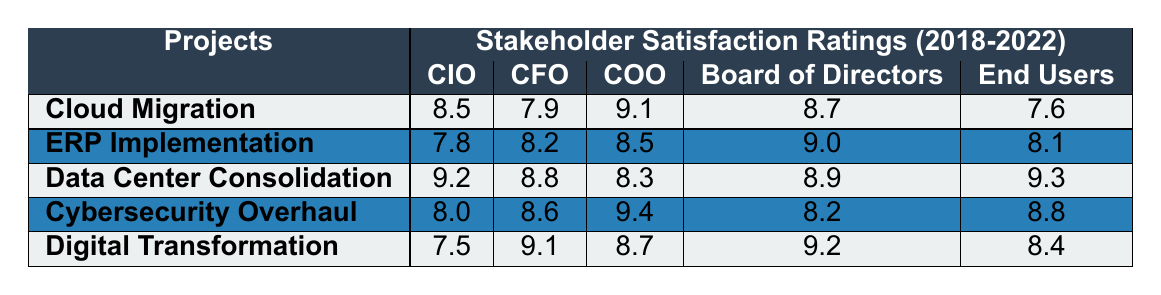What was the highest satisfaction rating for the CIO among all projects? The highest satisfaction rating for the CIO is 9.3, which corresponds to the "Data Center Consolidation" project in 2018.
Answer: 9.3 What is the average satisfaction rating for the CFO across all projects? To calculate the average for the CFO, we sum the ratings: (7.9 + 8.2 + 8.8 + 8.6 + 9.1) = 42.6. Dividing by 5 (the number of projects), we get 42.6/5 = 8.52.
Answer: 8.52 Which project received the lowest satisfaction rating from the Board of Directors? The project with the lowest rating from the Board of Directors is "Cybersecurity Overhaul," with a rating of 8.2 in 2021.
Answer: Cybersecurity Overhaul Did the satisfaction rating for End Users improve in the "Digital Transformation Initiative" project from 2018 to 2022? The End User rating for "Digital Transformation Initiative" initially was 7.5 in 2018 and rose to 8.4 in 2022. Therefore, the rating improved.
Answer: Yes Which project's ratings show the most significant decrease for the COO over the years? Examining COO ratings reveals "Cloud Migration" with ratings of 9.1 in 2018 and 8.3 in 2022 shows a decrease of 0.8, which is the highest decrease.
Answer: Cloud Migration What was the satisfaction rating for the cybersecurity overhaul from the CIO in 2019? The rating for the CIO regarding the Cybersecurity Overhaul project in 2019 is 8.6.
Answer: 8.6 What is the difference in satisfaction ratings between End Users and COO for the "Data Center Consolidation" project? For "Data Center Consolidation," the End Users rated it 9.3, and the COO rated it 8.3. The difference is 9.3 - 8.3 = 1.0.
Answer: 1.0 What percentage of the ratings for the CIO in all projects are above 8.0? The ratings for the CIO are 8.5, 7.8, 9.2, 8.0, and 7.5. Three ratings (8.5, 9.2, 8.0) are above 8.0. This is 3 out of 5, which is 60%.
Answer: 60% In which year did the "ERP Implementation" project receive its highest overall rating? The "ERP Implementation" project received its highest overall rating of 9.0 from the Board of Directors in 2021.
Answer: 2021 Which project received the most consistent ratings over the years (smallest variation among stakeholders)? "Cybersecurity Overhaul" had ratings of 8.0, 8.6, 9.4, 8.2, and 8.8, demonstrating the smallest variation among the projects.
Answer: Cybersecurity Overhaul 